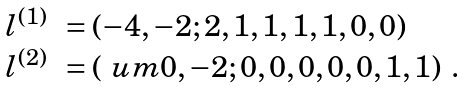Convert formula to latex. <formula><loc_0><loc_0><loc_500><loc_500>\begin{array} { r l } l ^ { ( 1 ) } & = ( - 4 , - 2 ; 2 , 1 , 1 , 1 , 1 , 0 , 0 ) \\ l ^ { ( 2 ) } & = ( \ u m 0 , - 2 ; 0 , 0 , 0 , 0 , 0 , 1 , 1 ) \ . \end{array}</formula> 